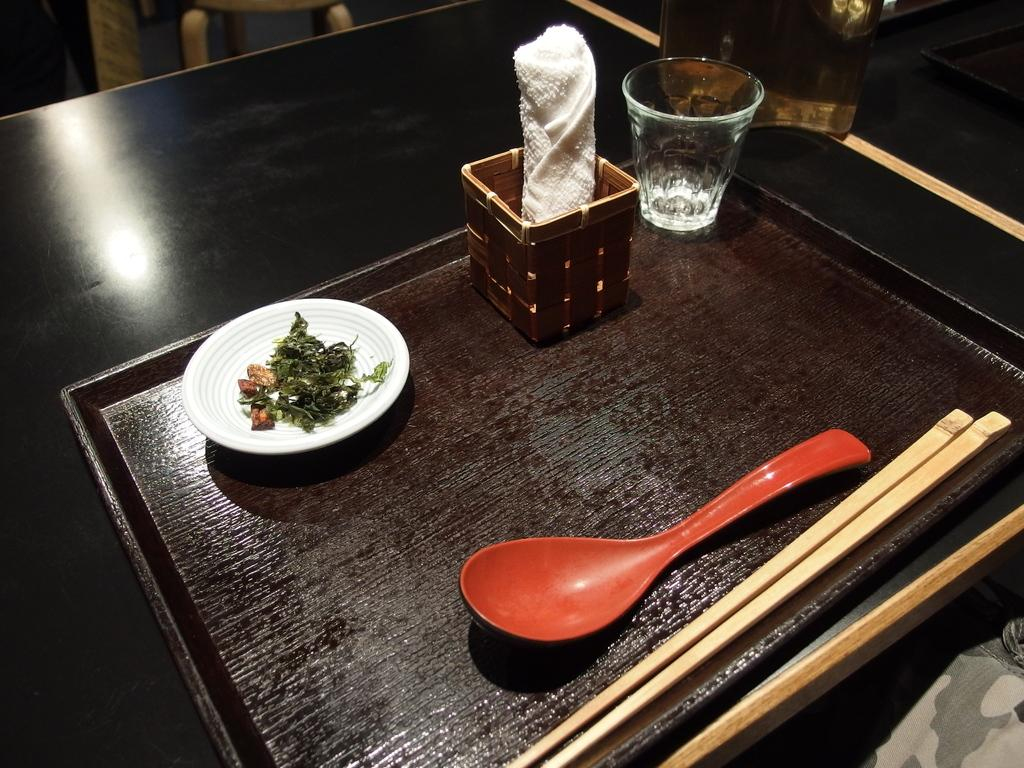What piece of furniture is present in the image? There is a table in the image. What is placed on the table? There is a tray on the table. What items are on the tray? The tray contains 2 sticks, one spoon, and a plate with eatables. What is used for cleaning or wiping in the image? There is a napkin on the table. What is used for drinking in the image? There is a glass on the table. What type of curtain is hanging near the table in the image? There is no curtain present in the image. How old is the son in the image? There is no son present in the image. 